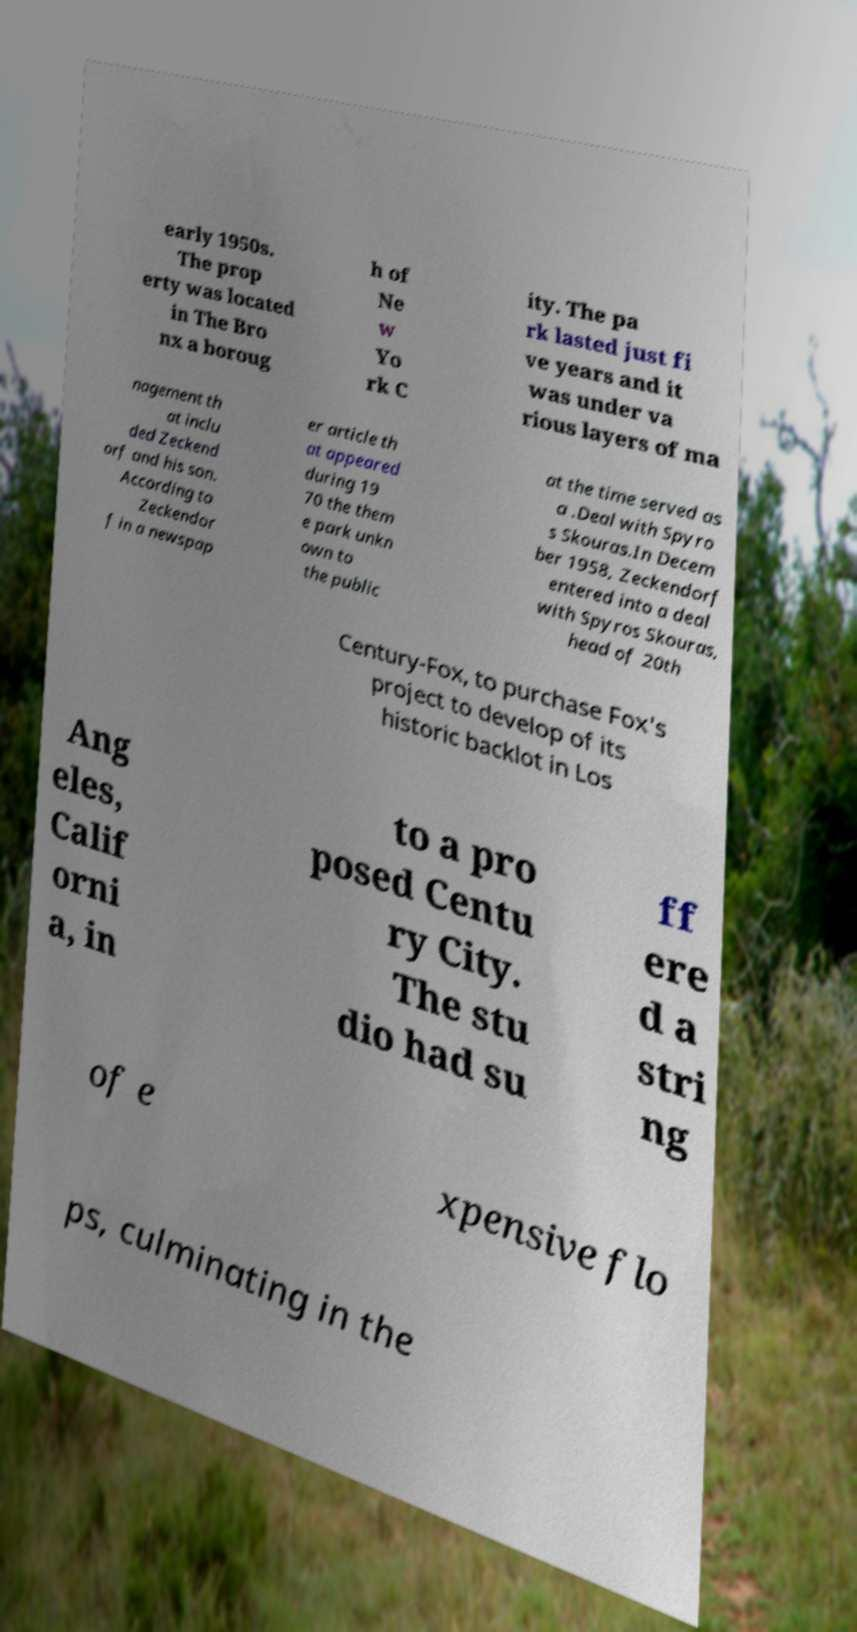Can you read and provide the text displayed in the image?This photo seems to have some interesting text. Can you extract and type it out for me? early 1950s. The prop erty was located in The Bro nx a boroug h of Ne w Yo rk C ity. The pa rk lasted just fi ve years and it was under va rious layers of ma nagement th at inclu ded Zeckend orf and his son. According to Zeckendor f in a newspap er article th at appeared during 19 70 the them e park unkn own to the public at the time served as a .Deal with Spyro s Skouras.In Decem ber 1958, Zeckendorf entered into a deal with Spyros Skouras, head of 20th Century-Fox, to purchase Fox's project to develop of its historic backlot in Los Ang eles, Calif orni a, in to a pro posed Centu ry City. The stu dio had su ff ere d a stri ng of e xpensive flo ps, culminating in the 